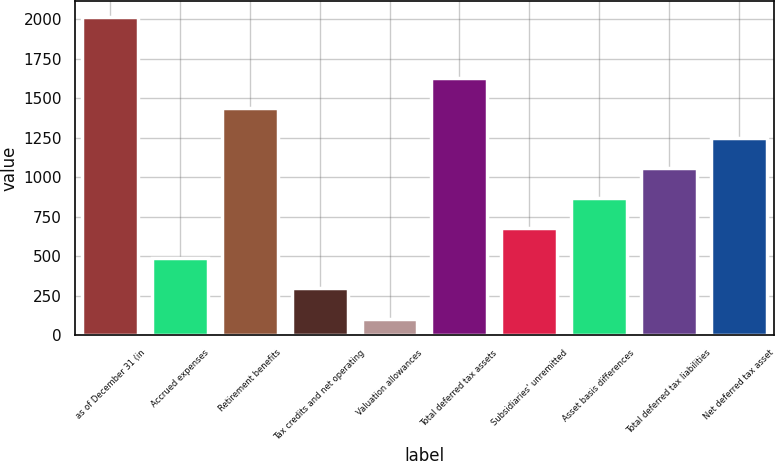Convert chart. <chart><loc_0><loc_0><loc_500><loc_500><bar_chart><fcel>as of December 31 (in<fcel>Accrued expenses<fcel>Retirement benefits<fcel>Tax credits and net operating<fcel>Valuation allowances<fcel>Total deferred tax assets<fcel>Subsidiaries' unremitted<fcel>Asset basis differences<fcel>Total deferred tax liabilities<fcel>Net deferred tax asset<nl><fcel>2012<fcel>485.6<fcel>1439.6<fcel>294.8<fcel>104<fcel>1630.4<fcel>676.4<fcel>867.2<fcel>1058<fcel>1248.8<nl></chart> 